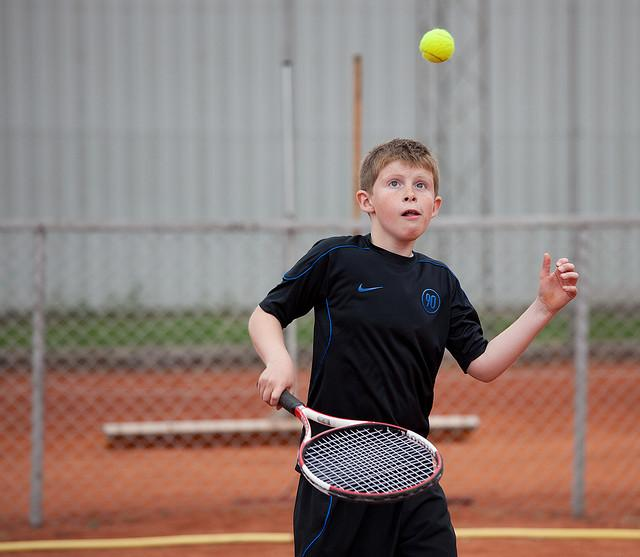What action will he take with the ball? Please explain your reasoning. swing. He needs to hit the ball to the other player 